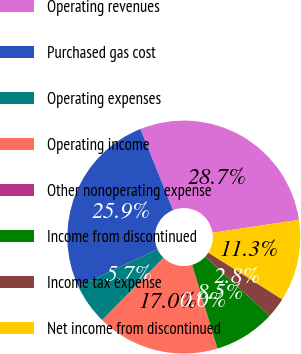Convert chart to OTSL. <chart><loc_0><loc_0><loc_500><loc_500><pie_chart><fcel>Operating revenues<fcel>Purchased gas cost<fcel>Operating expenses<fcel>Operating income<fcel>Other nonoperating expense<fcel>Income from discontinued<fcel>Income tax expense<fcel>Net income from discontinued<nl><fcel>28.72%<fcel>25.89%<fcel>5.68%<fcel>16.99%<fcel>0.02%<fcel>8.51%<fcel>2.85%<fcel>11.34%<nl></chart> 